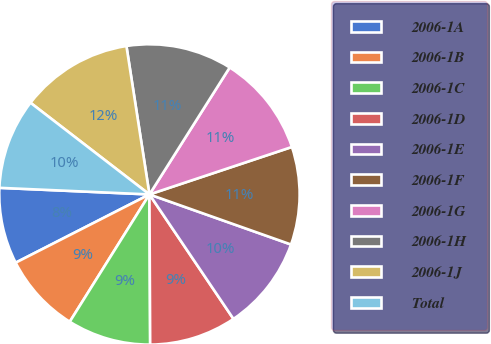Convert chart to OTSL. <chart><loc_0><loc_0><loc_500><loc_500><pie_chart><fcel>2006-1A<fcel>2006-1B<fcel>2006-1C<fcel>2006-1D<fcel>2006-1E<fcel>2006-1F<fcel>2006-1G<fcel>2006-1H<fcel>2006-1J<fcel>Total<nl><fcel>8.21%<fcel>8.59%<fcel>8.98%<fcel>9.37%<fcel>10.14%<fcel>10.53%<fcel>10.91%<fcel>11.42%<fcel>12.1%<fcel>9.75%<nl></chart> 